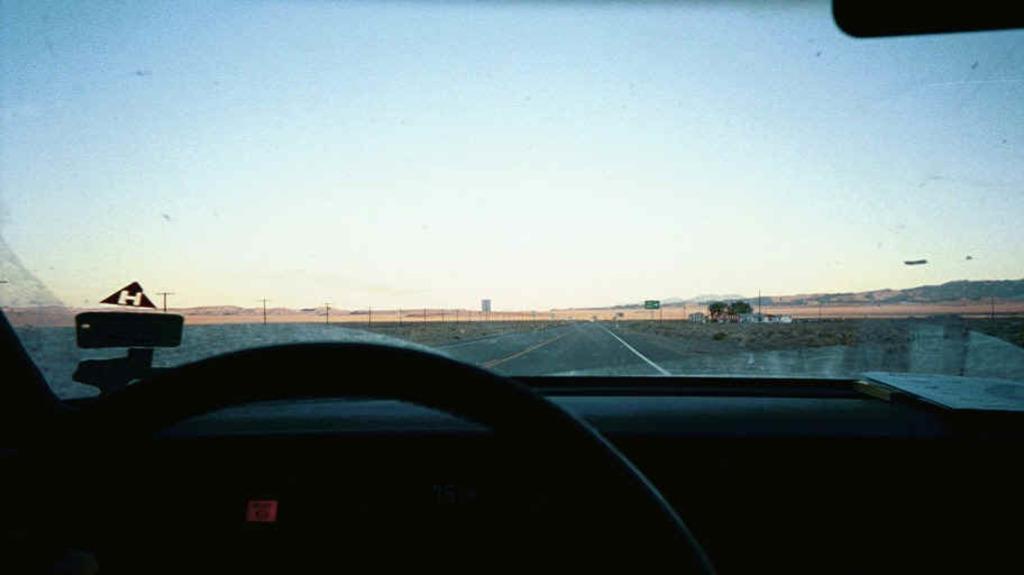How would you summarize this image in a sentence or two? In this image in front there is a car on the road. Beside the road there are poles and a sign board. In the background there are trees, building and sky. 